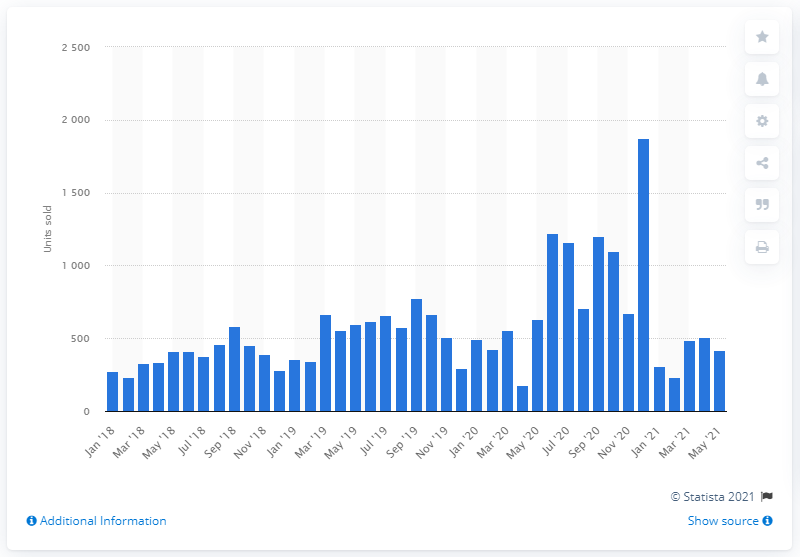Highlight a few significant elements in this photo. In May 2021, a total of 418 new Lexmoto motorcycles were sold in the UK. 